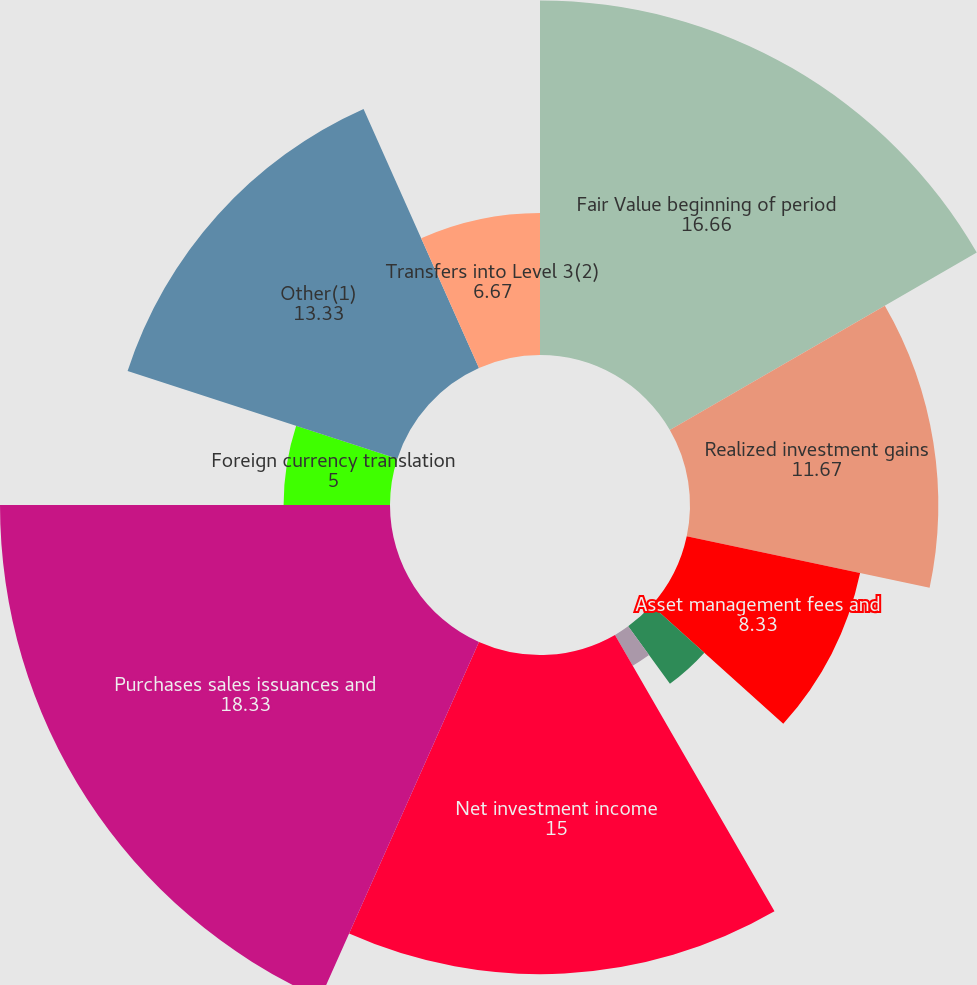Convert chart. <chart><loc_0><loc_0><loc_500><loc_500><pie_chart><fcel>Fair Value beginning of period<fcel>Realized investment gains<fcel>Asset management fees and<fcel>Interest credited to<fcel>Included in other<fcel>Net investment income<fcel>Purchases sales issuances and<fcel>Foreign currency translation<fcel>Other(1)<fcel>Transfers into Level 3(2)<nl><fcel>16.66%<fcel>11.67%<fcel>8.33%<fcel>3.34%<fcel>1.67%<fcel>15.0%<fcel>18.33%<fcel>5.0%<fcel>13.33%<fcel>6.67%<nl></chart> 